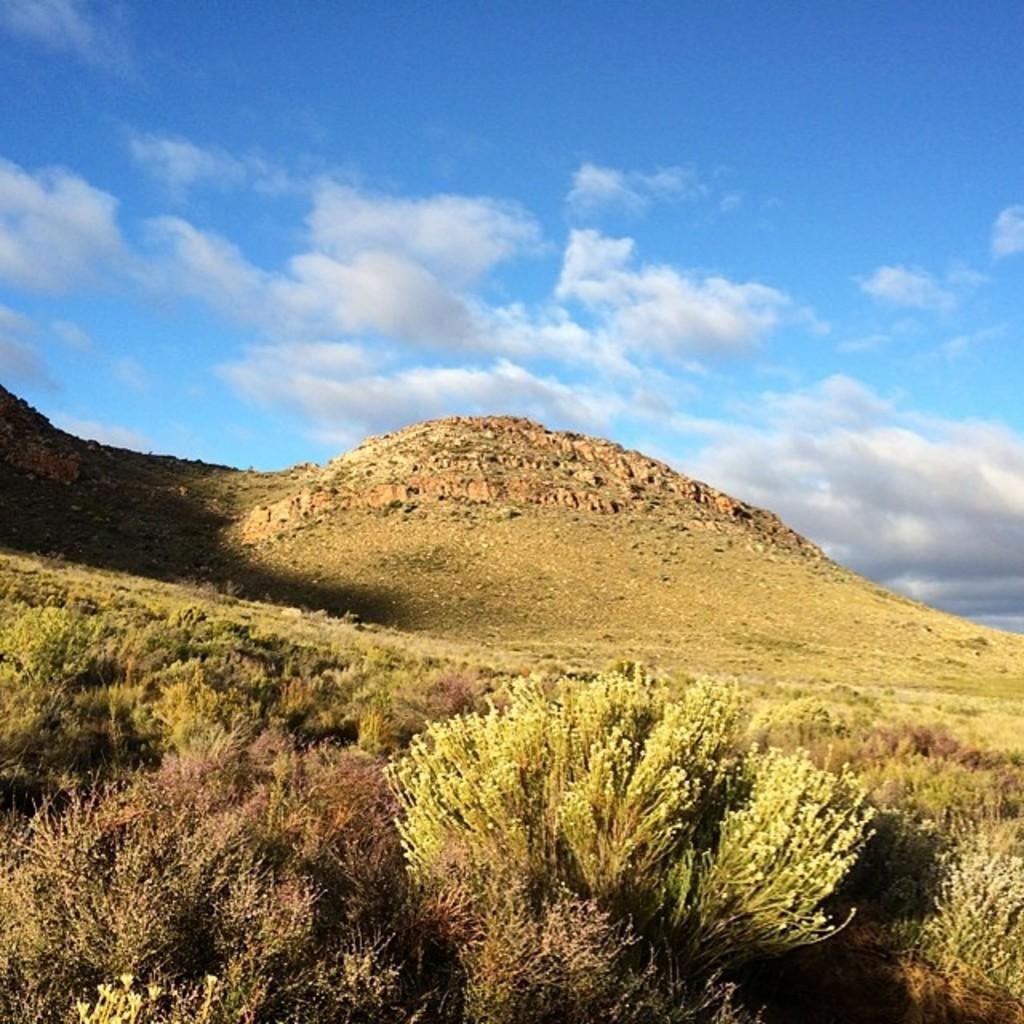What type of living organisms can be seen in the image? Plants can be seen in the image. What natural features are visible in the background of the image? There are mountains and the sky visible in the background of the image. What can be seen in the sky in the image? Clouds are present in the sky in the image. What type of record can be seen spinning on a turntable in the image? There is no record or turntable present in the image. 